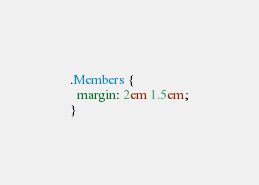<code> <loc_0><loc_0><loc_500><loc_500><_CSS_>.Members {
  margin: 2em 1.5em;
}
</code> 